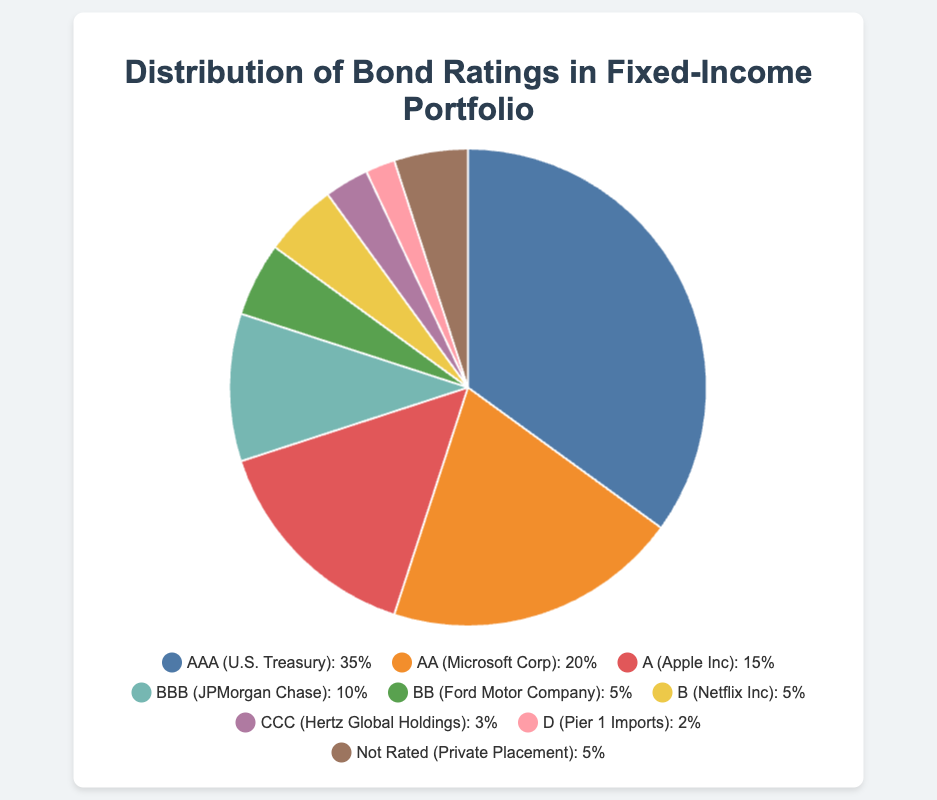Which bond rating has the highest percentage in the portfolio? The 'AAA' rating, associated with the U.S. Treasury, has the largest segment of the pie chart, indicating it's the highest percentage.
Answer: AAA What is the combined percentage of bonds rated 'B' and 'BB'? Bonds rated 'B' by Netflix Inc and 'BB' by Ford Motor Company both contribute 5% each. Summing these percentages gives 5 + 5 = 10%.
Answer: 10% How does the percentage of 'AAA' rated bonds compare to 'AA' rated bonds? 'AAA' rated bonds are 35%, and 'AA' rated bonds are 20%. 35% is greater than 20%, indicating 'AAA' bonds have a higher percentage.
Answer: 'AAA' > 'AA' What is the visual color representing the 'A' rated bond by Apple Inc? The 'A' rated bond segment, associated with Apple Inc, is colored orange in the pie chart.
Answer: Orange Which bond rating has the smallest representation in the portfolio? The 'D' rated bond, associated with Pier 1 Imports, is the smallest segment in the pie chart, representing 2%.
Answer: D What is the total percentage of bonds rated 'BBB' or lower? Summing up the percentages of 'BBB' (10%), 'BB' (5%), 'B' (5%), 'CCC' (3%), and 'D' (2%) gives 10 + 5 + 5 + 3 + 2 = 25%.
Answer: 25% How much more percentage do 'AAA' rated bonds have compared to 'A' rated bonds? 'AAA' rated bonds account for 35%, while 'A' rated bonds account for 15%. The difference is 35 - 15 = 20%.
Answer: 20% What is the percentage representation of unrated (Not Rated) bonds? The 'Not Rated' bond segment, associated with Private Placement, is 5% of the total portfolio.
Answer: 5% How does the total percentage of investment-grade bonds (AAA, AA, A, BBB) compare to the total percentage of non-investment-grade bonds (BB, B, CCC, D)? Investment-grade bonds account for AAA (35%) + AA (20%) + A (15%) + BBB (10%) = 80%. Non-investment-grade bonds account for BB (5%) + B (5%) + CCC (3%) + D (2%) = 15%.
Answer: 80% vs 15% What is the percentage difference between 'AAA' and 'Not Rated' bonds? 'AAA' rated bonds are 35%, while 'Not Rated' bonds are 5%. The percentage difference is 35 - 5 = 30%.
Answer: 30% 